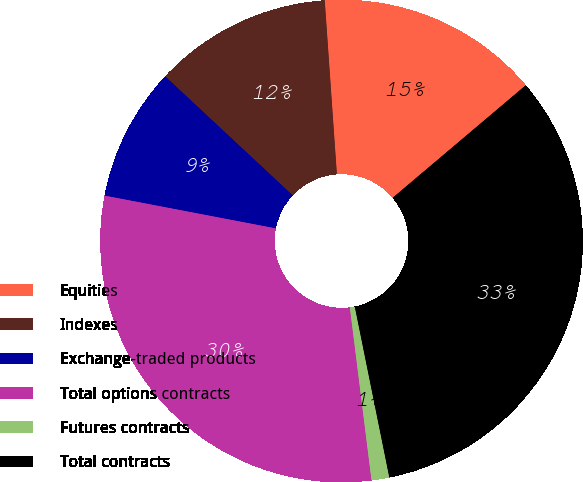<chart> <loc_0><loc_0><loc_500><loc_500><pie_chart><fcel>Equities<fcel>Indexes<fcel>Exchange-traded products<fcel>Total options contracts<fcel>Futures contracts<fcel>Total contracts<nl><fcel>14.94%<fcel>11.94%<fcel>8.94%<fcel>30.0%<fcel>1.19%<fcel>33.0%<nl></chart> 